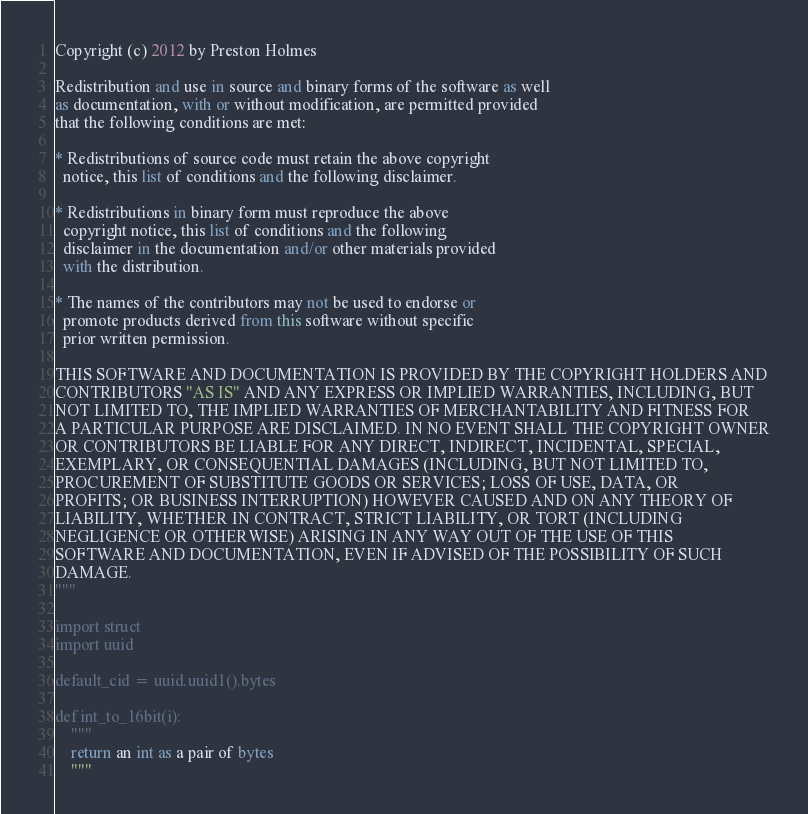<code> <loc_0><loc_0><loc_500><loc_500><_Python_>Copyright (c) 2012 by Preston Holmes

Redistribution and use in source and binary forms of the software as well
as documentation, with or without modification, are permitted provided
that the following conditions are met:

* Redistributions of source code must retain the above copyright
  notice, this list of conditions and the following disclaimer.

* Redistributions in binary form must reproduce the above
  copyright notice, this list of conditions and the following
  disclaimer in the documentation and/or other materials provided
  with the distribution.

* The names of the contributors may not be used to endorse or
  promote products derived from this software without specific
  prior written permission.

THIS SOFTWARE AND DOCUMENTATION IS PROVIDED BY THE COPYRIGHT HOLDERS AND
CONTRIBUTORS "AS IS" AND ANY EXPRESS OR IMPLIED WARRANTIES, INCLUDING, BUT
NOT LIMITED TO, THE IMPLIED WARRANTIES OF MERCHANTABILITY AND FITNESS FOR
A PARTICULAR PURPOSE ARE DISCLAIMED. IN NO EVENT SHALL THE COPYRIGHT OWNER
OR CONTRIBUTORS BE LIABLE FOR ANY DIRECT, INDIRECT, INCIDENTAL, SPECIAL,
EXEMPLARY, OR CONSEQUENTIAL DAMAGES (INCLUDING, BUT NOT LIMITED TO,
PROCUREMENT OF SUBSTITUTE GOODS OR SERVICES; LOSS OF USE, DATA, OR
PROFITS; OR BUSINESS INTERRUPTION) HOWEVER CAUSED AND ON ANY THEORY OF
LIABILITY, WHETHER IN CONTRACT, STRICT LIABILITY, OR TORT (INCLUDING
NEGLIGENCE OR OTHERWISE) ARISING IN ANY WAY OUT OF THE USE OF THIS
SOFTWARE AND DOCUMENTATION, EVEN IF ADVISED OF THE POSSIBILITY OF SUCH
DAMAGE.
"""

import struct
import uuid

default_cid = uuid.uuid1().bytes

def int_to_16bit(i):
    """
    return an int as a pair of bytes
    """</code> 